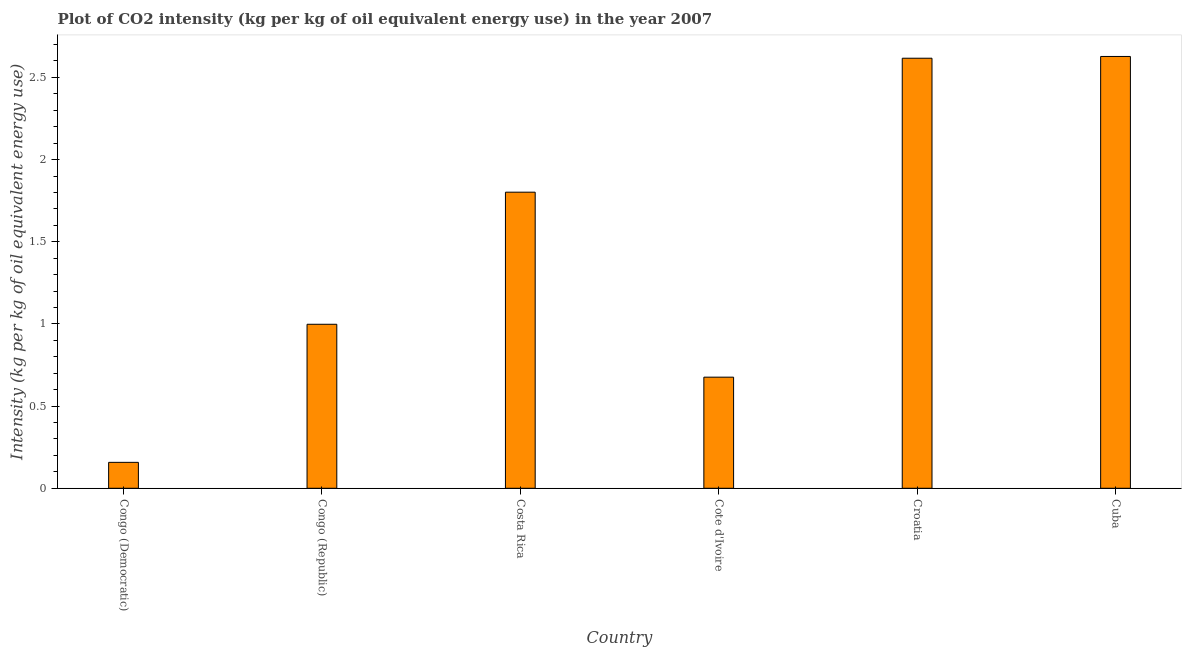Does the graph contain grids?
Ensure brevity in your answer.  No. What is the title of the graph?
Provide a succinct answer. Plot of CO2 intensity (kg per kg of oil equivalent energy use) in the year 2007. What is the label or title of the Y-axis?
Offer a terse response. Intensity (kg per kg of oil equivalent energy use). What is the co2 intensity in Cote d'Ivoire?
Keep it short and to the point. 0.68. Across all countries, what is the maximum co2 intensity?
Offer a very short reply. 2.63. Across all countries, what is the minimum co2 intensity?
Offer a terse response. 0.16. In which country was the co2 intensity maximum?
Provide a short and direct response. Cuba. In which country was the co2 intensity minimum?
Keep it short and to the point. Congo (Democratic). What is the sum of the co2 intensity?
Offer a very short reply. 8.88. What is the difference between the co2 intensity in Congo (Democratic) and Congo (Republic)?
Your answer should be compact. -0.84. What is the average co2 intensity per country?
Your answer should be very brief. 1.48. What is the median co2 intensity?
Your response must be concise. 1.4. In how many countries, is the co2 intensity greater than 0.4 kg?
Offer a very short reply. 5. What is the ratio of the co2 intensity in Costa Rica to that in Croatia?
Keep it short and to the point. 0.69. Is the difference between the co2 intensity in Congo (Republic) and Cuba greater than the difference between any two countries?
Offer a very short reply. No. What is the difference between the highest and the second highest co2 intensity?
Give a very brief answer. 0.01. What is the difference between the highest and the lowest co2 intensity?
Provide a succinct answer. 2.47. In how many countries, is the co2 intensity greater than the average co2 intensity taken over all countries?
Ensure brevity in your answer.  3. Are all the bars in the graph horizontal?
Your answer should be very brief. No. How many countries are there in the graph?
Provide a short and direct response. 6. What is the difference between two consecutive major ticks on the Y-axis?
Offer a terse response. 0.5. Are the values on the major ticks of Y-axis written in scientific E-notation?
Offer a terse response. No. What is the Intensity (kg per kg of oil equivalent energy use) in Congo (Democratic)?
Your response must be concise. 0.16. What is the Intensity (kg per kg of oil equivalent energy use) in Congo (Republic)?
Your answer should be compact. 1. What is the Intensity (kg per kg of oil equivalent energy use) of Costa Rica?
Provide a succinct answer. 1.8. What is the Intensity (kg per kg of oil equivalent energy use) in Cote d'Ivoire?
Your answer should be very brief. 0.68. What is the Intensity (kg per kg of oil equivalent energy use) of Croatia?
Give a very brief answer. 2.62. What is the Intensity (kg per kg of oil equivalent energy use) of Cuba?
Give a very brief answer. 2.63. What is the difference between the Intensity (kg per kg of oil equivalent energy use) in Congo (Democratic) and Congo (Republic)?
Offer a terse response. -0.84. What is the difference between the Intensity (kg per kg of oil equivalent energy use) in Congo (Democratic) and Costa Rica?
Make the answer very short. -1.64. What is the difference between the Intensity (kg per kg of oil equivalent energy use) in Congo (Democratic) and Cote d'Ivoire?
Make the answer very short. -0.52. What is the difference between the Intensity (kg per kg of oil equivalent energy use) in Congo (Democratic) and Croatia?
Keep it short and to the point. -2.46. What is the difference between the Intensity (kg per kg of oil equivalent energy use) in Congo (Democratic) and Cuba?
Your answer should be compact. -2.47. What is the difference between the Intensity (kg per kg of oil equivalent energy use) in Congo (Republic) and Costa Rica?
Give a very brief answer. -0.8. What is the difference between the Intensity (kg per kg of oil equivalent energy use) in Congo (Republic) and Cote d'Ivoire?
Offer a terse response. 0.32. What is the difference between the Intensity (kg per kg of oil equivalent energy use) in Congo (Republic) and Croatia?
Your answer should be very brief. -1.62. What is the difference between the Intensity (kg per kg of oil equivalent energy use) in Congo (Republic) and Cuba?
Keep it short and to the point. -1.63. What is the difference between the Intensity (kg per kg of oil equivalent energy use) in Costa Rica and Cote d'Ivoire?
Provide a succinct answer. 1.13. What is the difference between the Intensity (kg per kg of oil equivalent energy use) in Costa Rica and Croatia?
Offer a very short reply. -0.82. What is the difference between the Intensity (kg per kg of oil equivalent energy use) in Costa Rica and Cuba?
Ensure brevity in your answer.  -0.83. What is the difference between the Intensity (kg per kg of oil equivalent energy use) in Cote d'Ivoire and Croatia?
Offer a terse response. -1.94. What is the difference between the Intensity (kg per kg of oil equivalent energy use) in Cote d'Ivoire and Cuba?
Ensure brevity in your answer.  -1.95. What is the difference between the Intensity (kg per kg of oil equivalent energy use) in Croatia and Cuba?
Provide a short and direct response. -0.01. What is the ratio of the Intensity (kg per kg of oil equivalent energy use) in Congo (Democratic) to that in Congo (Republic)?
Offer a terse response. 0.16. What is the ratio of the Intensity (kg per kg of oil equivalent energy use) in Congo (Democratic) to that in Costa Rica?
Make the answer very short. 0.09. What is the ratio of the Intensity (kg per kg of oil equivalent energy use) in Congo (Democratic) to that in Cote d'Ivoire?
Your response must be concise. 0.23. What is the ratio of the Intensity (kg per kg of oil equivalent energy use) in Congo (Republic) to that in Costa Rica?
Your answer should be compact. 0.55. What is the ratio of the Intensity (kg per kg of oil equivalent energy use) in Congo (Republic) to that in Cote d'Ivoire?
Provide a short and direct response. 1.48. What is the ratio of the Intensity (kg per kg of oil equivalent energy use) in Congo (Republic) to that in Croatia?
Your response must be concise. 0.38. What is the ratio of the Intensity (kg per kg of oil equivalent energy use) in Congo (Republic) to that in Cuba?
Keep it short and to the point. 0.38. What is the ratio of the Intensity (kg per kg of oil equivalent energy use) in Costa Rica to that in Cote d'Ivoire?
Your answer should be compact. 2.67. What is the ratio of the Intensity (kg per kg of oil equivalent energy use) in Costa Rica to that in Croatia?
Your answer should be very brief. 0.69. What is the ratio of the Intensity (kg per kg of oil equivalent energy use) in Costa Rica to that in Cuba?
Give a very brief answer. 0.69. What is the ratio of the Intensity (kg per kg of oil equivalent energy use) in Cote d'Ivoire to that in Croatia?
Provide a succinct answer. 0.26. What is the ratio of the Intensity (kg per kg of oil equivalent energy use) in Cote d'Ivoire to that in Cuba?
Offer a very short reply. 0.26. 